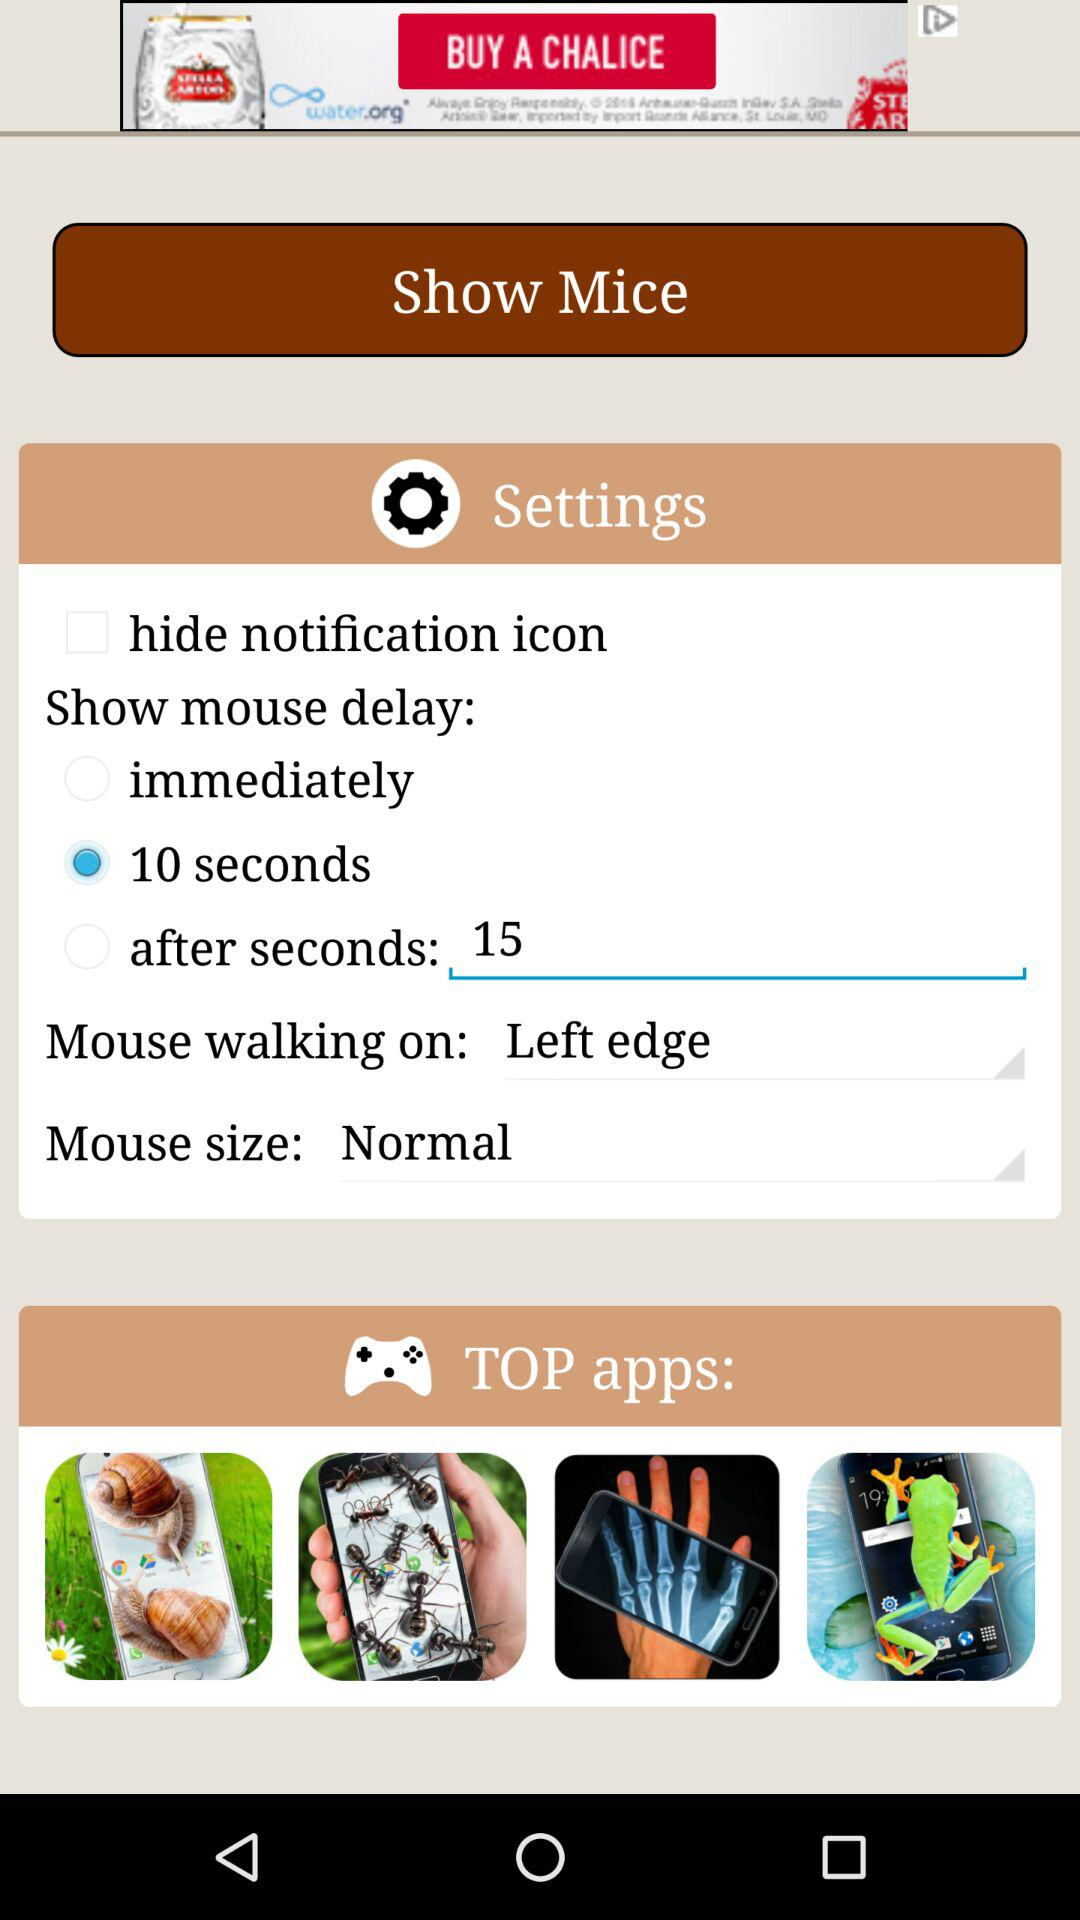How many seconds does it take for the mouse to appear after the app is opened?
Answer the question using a single word or phrase. 15 